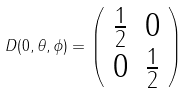<formula> <loc_0><loc_0><loc_500><loc_500>D ( 0 , \theta , \phi ) = \left ( \begin{array} { c c } \frac { 1 } { 2 } & 0 \\ 0 & \frac { 1 } { 2 } \end{array} \right )</formula> 